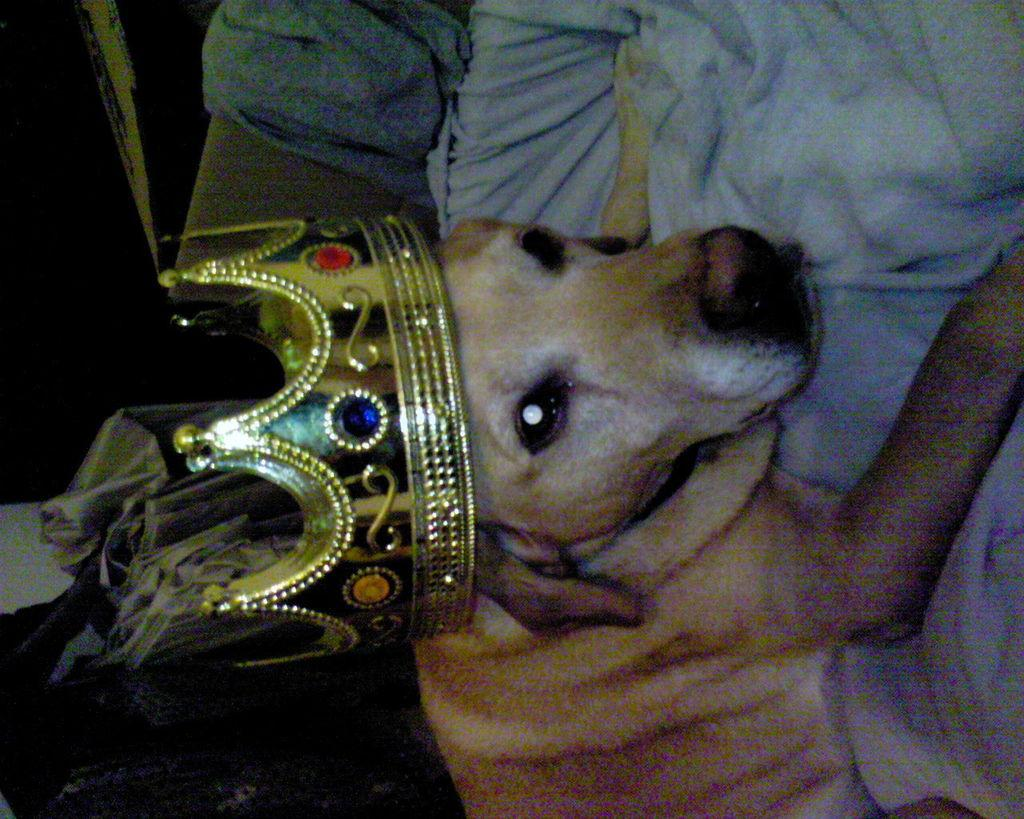What is happening in the image? There is a person in the image holding a dog. Can you describe the dog in the image? The dog is wearing a crown. What can be seen in the background of the image? There are objects in the background of the image. What type of truck is visible in the image? There is no truck present in the image. Who is the partner of the person in the image? The image only shows a person holding a dog, so there is no indication of a partner. 